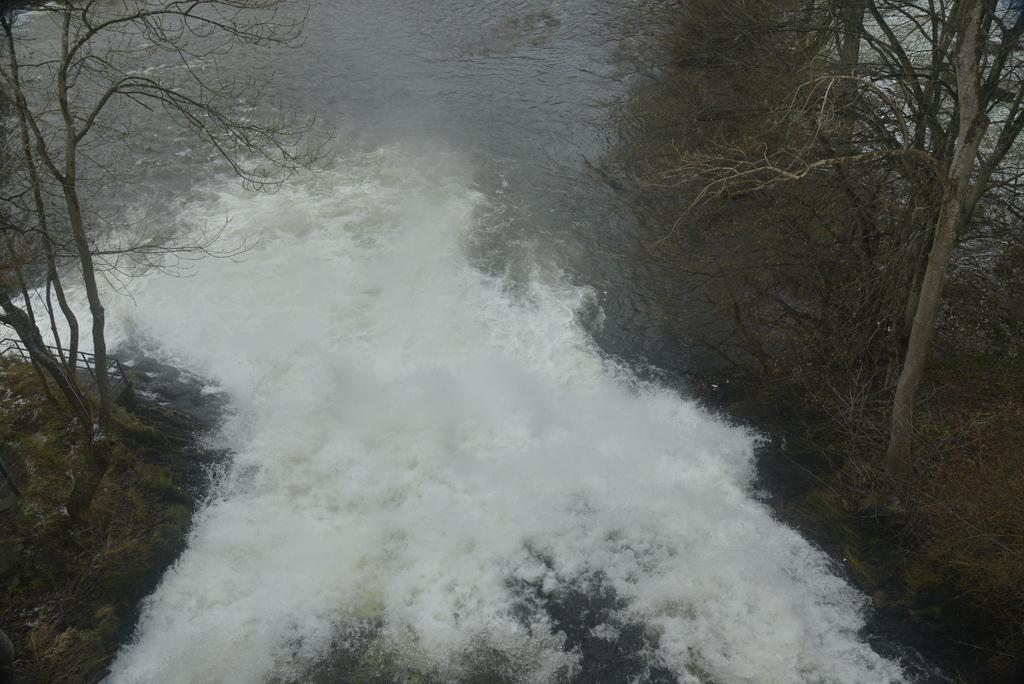What is happening in the image? Water is flowing in the image. Where is the tree located in the image? There is a tree on the right side of the image. Can you see a kitten playing with a cracker in the image? No, there is no kitten or cracker present in the image. 